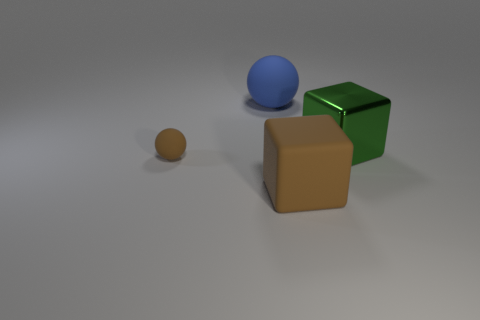What number of large green blocks are the same material as the large blue object?
Your answer should be compact. 0. What color is the block that is the same material as the tiny object?
Keep it short and to the point. Brown. Is the number of brown rubber cubes less than the number of big green matte cubes?
Offer a terse response. No. There is a large thing that is in front of the big block on the right side of the rubber cube that is to the left of the large green cube; what is it made of?
Your answer should be compact. Rubber. What is the brown ball made of?
Ensure brevity in your answer.  Rubber. Is the color of the block in front of the green metal cube the same as the block that is to the right of the big brown matte block?
Ensure brevity in your answer.  No. Is the number of large blue rubber cylinders greater than the number of blue spheres?
Give a very brief answer. No. What number of other rubber things have the same color as the tiny matte thing?
Offer a terse response. 1. What is the color of the metal object that is the same shape as the big brown matte object?
Provide a succinct answer. Green. What material is the big thing that is both in front of the large blue thing and behind the large brown rubber thing?
Offer a terse response. Metal. 